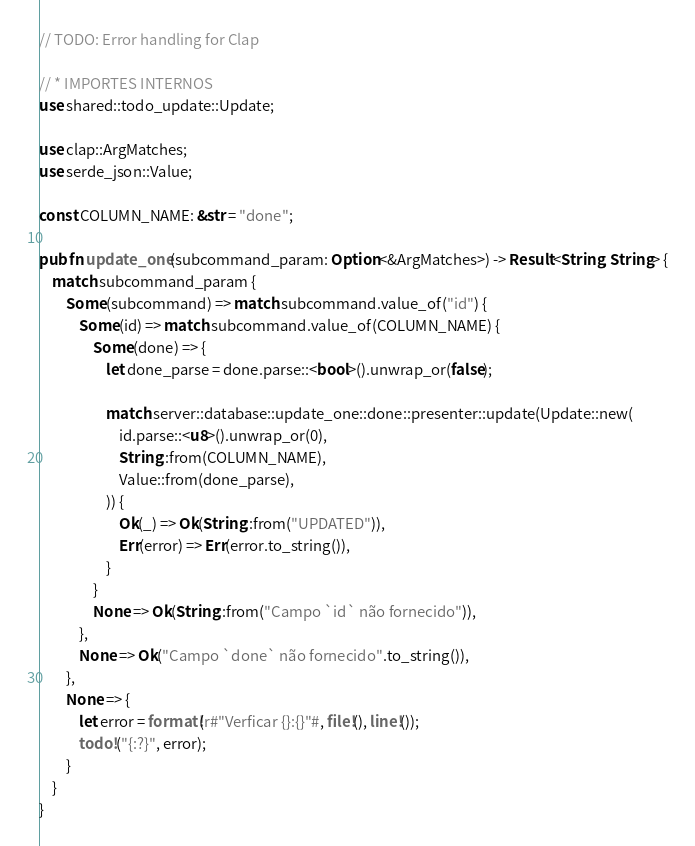<code> <loc_0><loc_0><loc_500><loc_500><_Rust_>// TODO: Error handling for Clap

// * IMPORTES INTERNOS
use shared::todo_update::Update;

use clap::ArgMatches;
use serde_json::Value;

const COLUMN_NAME: &str = "done";

pub fn update_one(subcommand_param: Option<&ArgMatches>) -> Result<String, String> {
    match subcommand_param {
        Some(subcommand) => match subcommand.value_of("id") {
            Some(id) => match subcommand.value_of(COLUMN_NAME) {
                Some(done) => {
                    let done_parse = done.parse::<bool>().unwrap_or(false);

                    match server::database::update_one::done::presenter::update(Update::new(
                        id.parse::<u8>().unwrap_or(0),
                        String::from(COLUMN_NAME),
                        Value::from(done_parse),
                    )) {
                        Ok(_) => Ok(String::from("UPDATED")),
                        Err(error) => Err(error.to_string()),
                    }
                }
                None => Ok(String::from("Campo `id` não fornecido")),
            },
            None => Ok("Campo `done` não fornecido".to_string()),
        },
        None => {
            let error = format!(r#"Verficar {}:{}"#, file!(), line!());
            todo!("{:?}", error);
        }
    }
}
</code> 